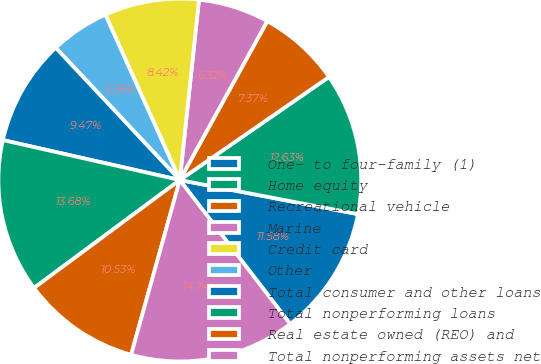<chart> <loc_0><loc_0><loc_500><loc_500><pie_chart><fcel>One- to four-family (1)<fcel>Home equity<fcel>Recreational vehicle<fcel>Marine<fcel>Credit card<fcel>Other<fcel>Total consumer and other loans<fcel>Total nonperforming loans<fcel>Real estate owned (REO) and<fcel>Total nonperforming assets net<nl><fcel>11.58%<fcel>12.63%<fcel>7.37%<fcel>6.32%<fcel>8.42%<fcel>5.26%<fcel>9.47%<fcel>13.68%<fcel>10.53%<fcel>14.74%<nl></chart> 